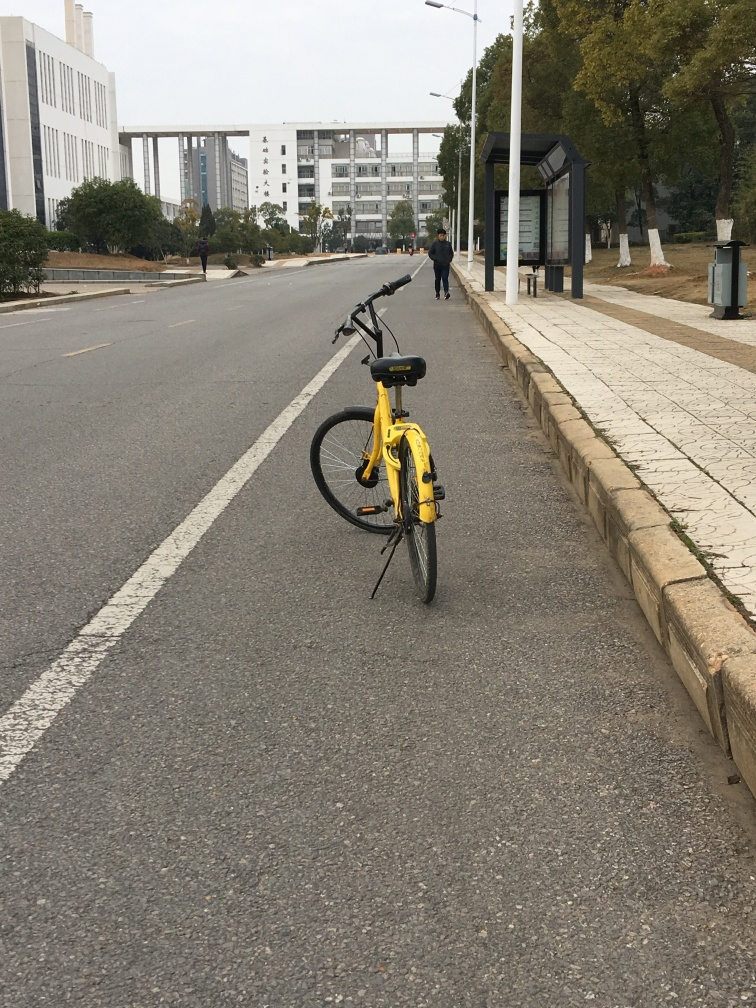Has this bicycle been abandoned, or is the owner nearby? While we can't infer the intentions of the owner, the bicycle's position on the side of the road suggests that it may have been parked temporarily, possibly with the owner not far away. However, without a lock or any personal belongings attached, it could also have been abandoned. 